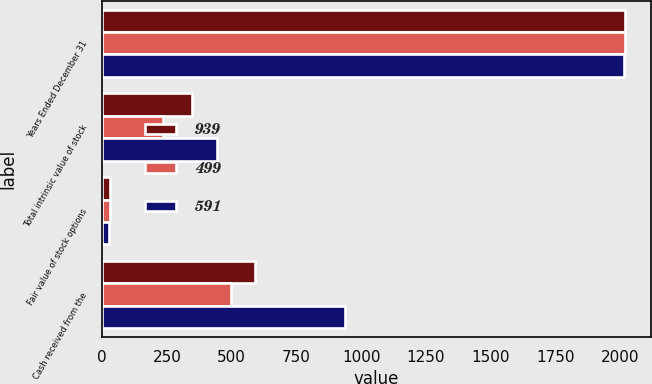Convert chart to OTSL. <chart><loc_0><loc_0><loc_500><loc_500><stacked_bar_chart><ecel><fcel>Years Ended December 31<fcel>Total intrinsic value of stock<fcel>Fair value of stock options<fcel>Cash received from the<nl><fcel>939<fcel>2018<fcel>348<fcel>29<fcel>591<nl><fcel>499<fcel>2017<fcel>236<fcel>30<fcel>499<nl><fcel>591<fcel>2016<fcel>444<fcel>28<fcel>939<nl></chart> 